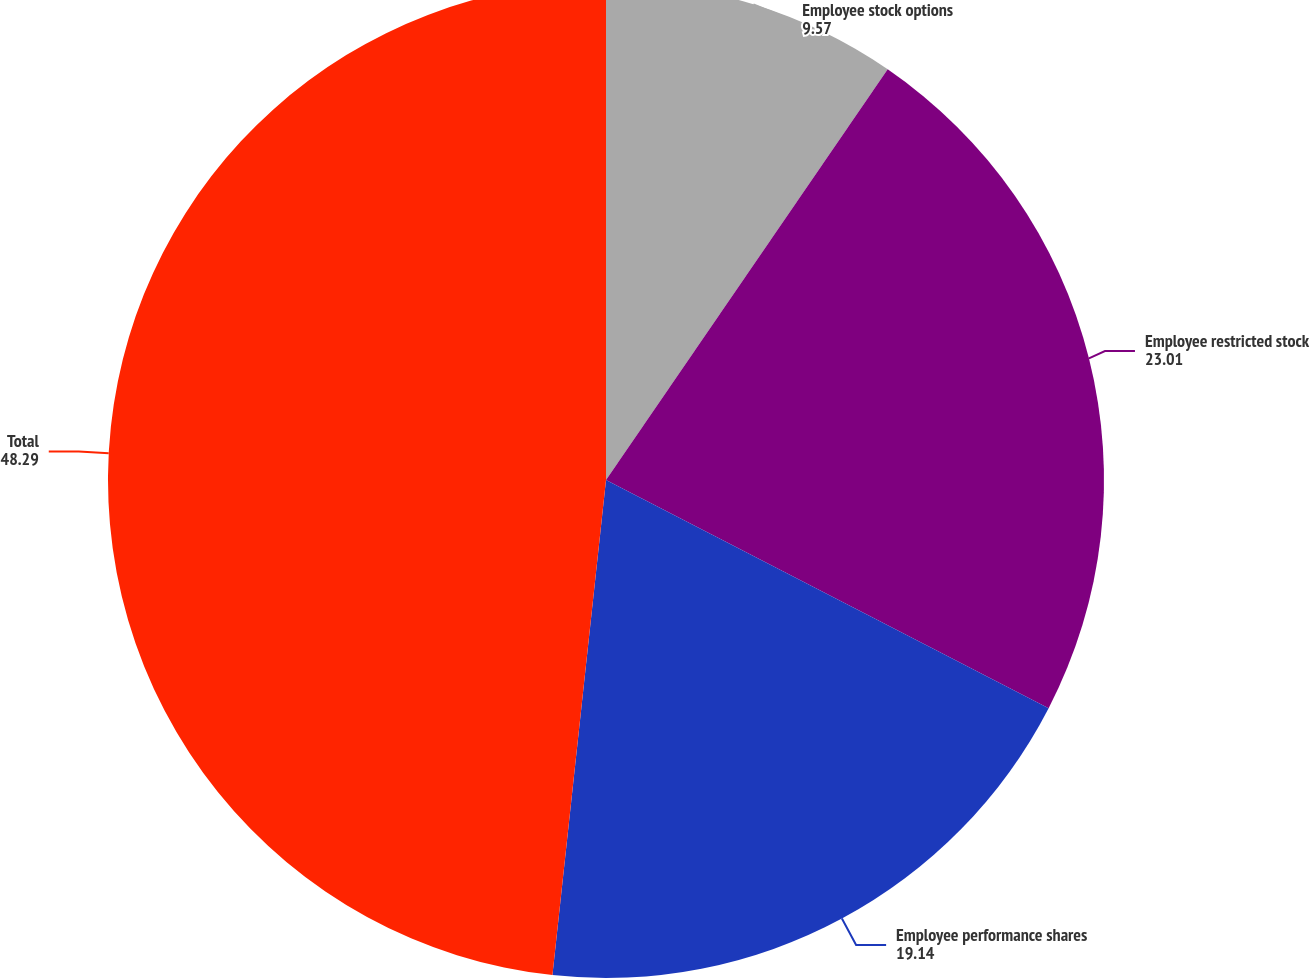Convert chart. <chart><loc_0><loc_0><loc_500><loc_500><pie_chart><fcel>Employee stock options<fcel>Employee restricted stock<fcel>Employee performance shares<fcel>Total<nl><fcel>9.57%<fcel>23.01%<fcel>19.14%<fcel>48.29%<nl></chart> 